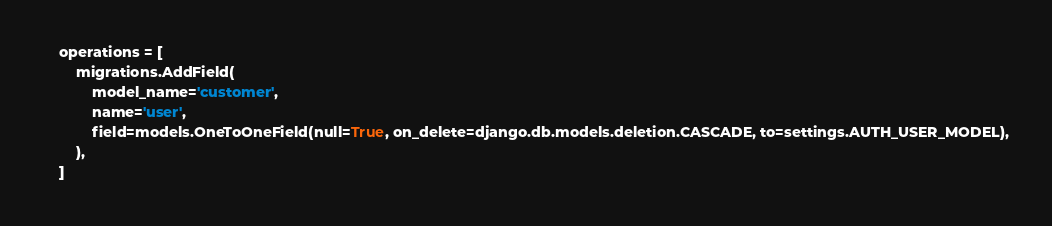<code> <loc_0><loc_0><loc_500><loc_500><_Python_>    operations = [
        migrations.AddField(
            model_name='customer',
            name='user',
            field=models.OneToOneField(null=True, on_delete=django.db.models.deletion.CASCADE, to=settings.AUTH_USER_MODEL),
        ),
    ]
</code> 